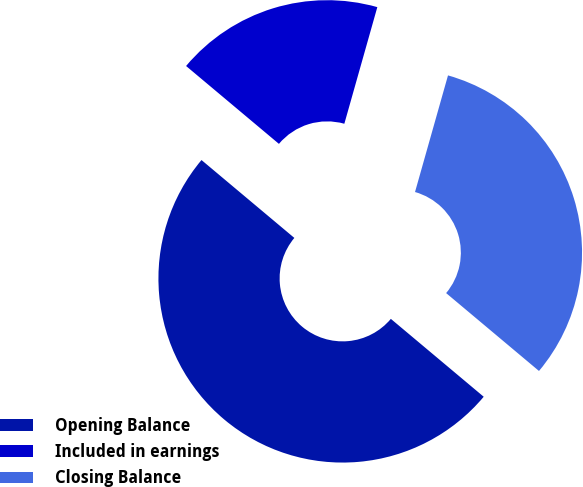Convert chart. <chart><loc_0><loc_0><loc_500><loc_500><pie_chart><fcel>Opening Balance<fcel>Included in earnings<fcel>Closing Balance<nl><fcel>50.0%<fcel>18.28%<fcel>31.72%<nl></chart> 